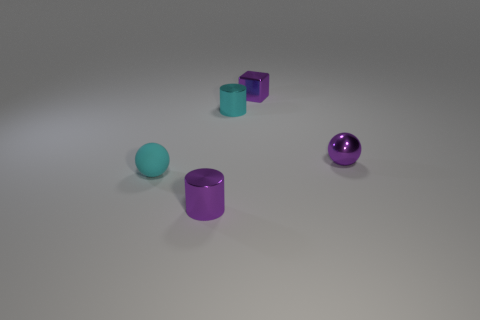Add 4 brown cylinders. How many objects exist? 9 Subtract all cubes. How many objects are left? 4 Subtract all green blocks. How many cyan cylinders are left? 1 Subtract all tiny red rubber blocks. Subtract all cyan matte balls. How many objects are left? 4 Add 3 small purple spheres. How many small purple spheres are left? 4 Add 2 small metallic cylinders. How many small metallic cylinders exist? 4 Subtract 0 green balls. How many objects are left? 5 Subtract 1 blocks. How many blocks are left? 0 Subtract all green balls. Subtract all purple blocks. How many balls are left? 2 